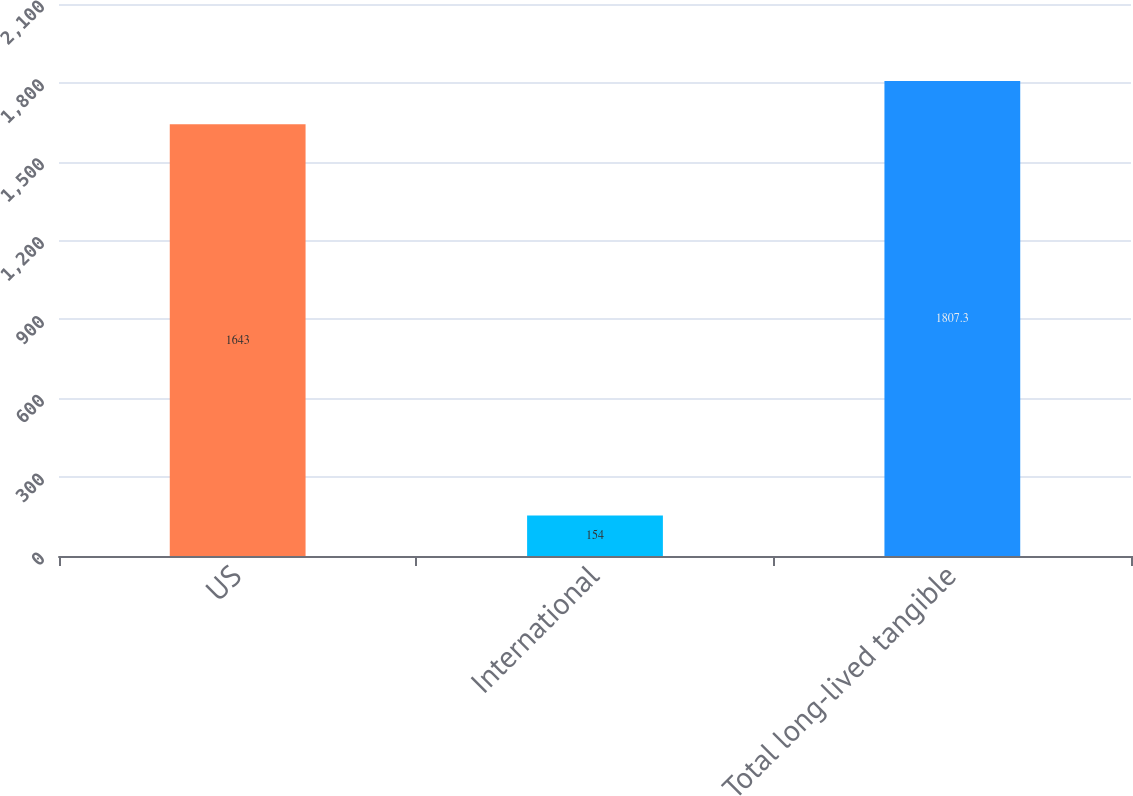<chart> <loc_0><loc_0><loc_500><loc_500><bar_chart><fcel>US<fcel>International<fcel>Total long-lived tangible<nl><fcel>1643<fcel>154<fcel>1807.3<nl></chart> 